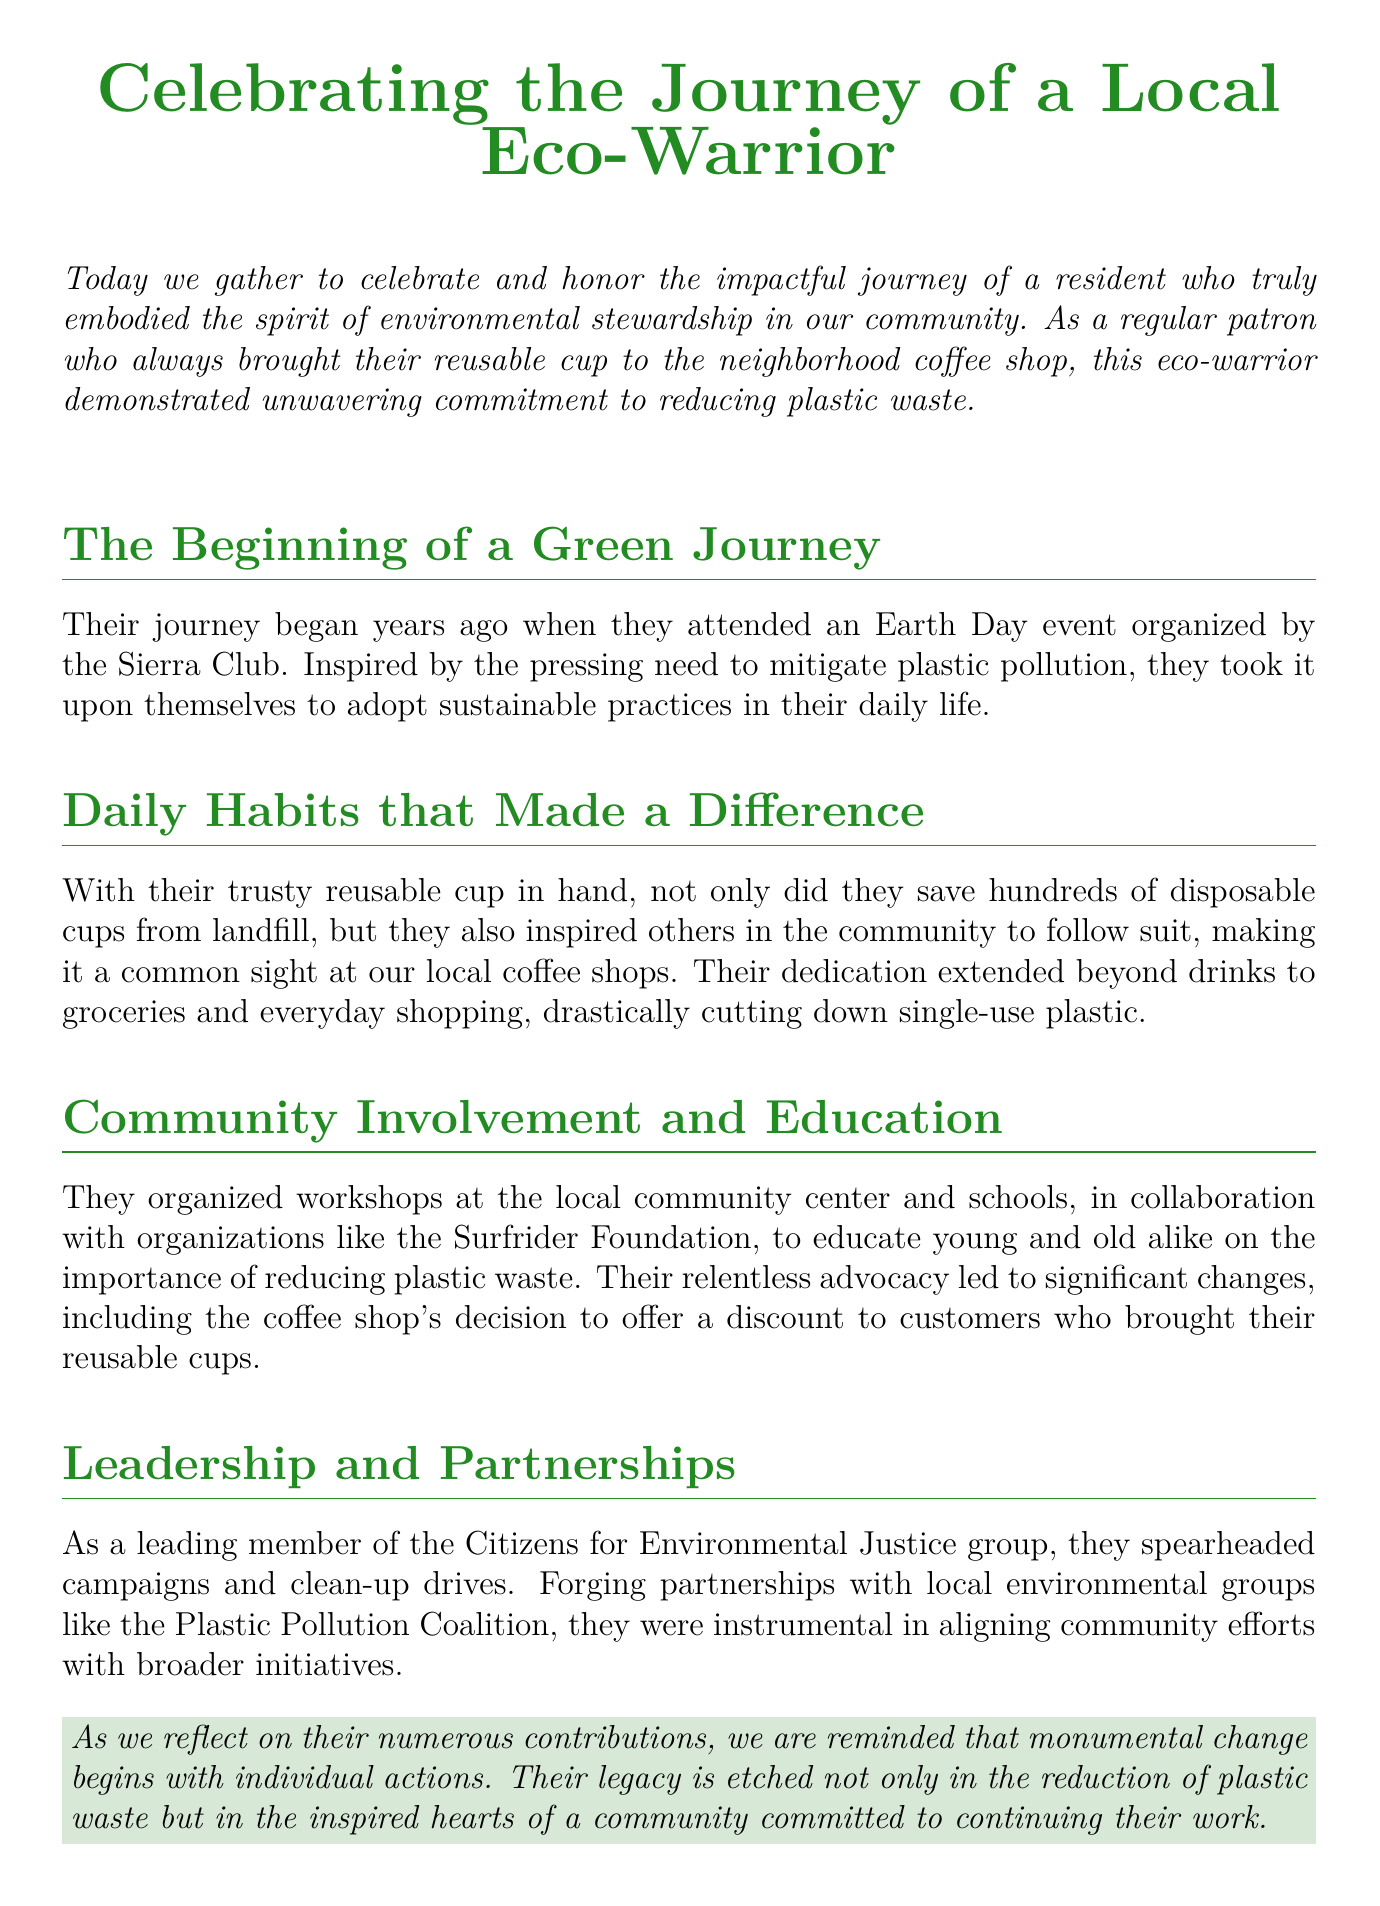What event inspired the eco-warrior? The eco-warrior's journey began when they attended an Earth Day event organized by the Sierra Club.
Answer: Earth Day event What did the eco-warrior regularly bring to the coffee shop? They regularly brought their reusable cup to the coffee shop, which helped reduce disposable cup waste.
Answer: Reusable cup Which organization collaborated with the eco-warrior for workshops? The eco-warrior organized workshops in collaboration with organizations like the Surfrider Foundation to promote environmental education.
Answer: Surfrider Foundation What significant change did the coffee shop implement due to the eco-warrior's efforts? The coffee shop decided to offer a discount to customers who brought their reusable cups, promoting sustainable practices.
Answer: Discount Which community group did the eco-warrior help lead? The eco-warrior was a leading member of the Citizens for Environmental Justice group, advocating for environmental issues.
Answer: Citizens for Environmental Justice What is the overarching theme reflected in the eulogy? The eulogy reflects the theme that monumental change begins with individual actions, highlighting the eco-warrior's impact on the community's environmental efforts.
Answer: Individual actions How did the eco-warrior inspire others in the community? By consistently using their reusable cup, they inspired others in the community to adopt sustainable practices as well.
Answer: Inspired others What type of drives did the eco-warrior spearhead? The eco-warrior spearheaded clean-up drives as part of their community involvement and environmental advocacy.
Answer: Clean-up drives 